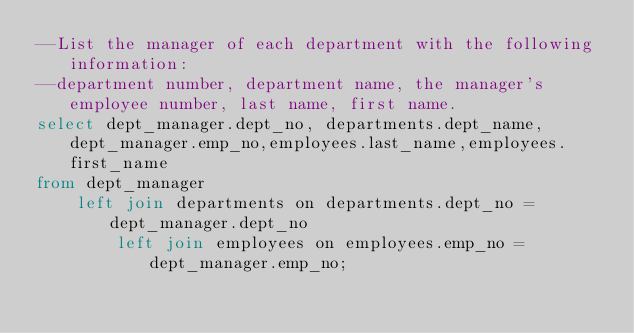<code> <loc_0><loc_0><loc_500><loc_500><_SQL_>--List the manager of each department with the following information:
--department number, department name, the manager's employee number, last name, first name.
select dept_manager.dept_no, departments.dept_name,dept_manager.emp_no,employees.last_name,employees.first_name
from dept_manager	
	left join departments on departments.dept_no = dept_manager.dept_no
		left join employees on employees.emp_no = dept_manager.emp_no;</code> 